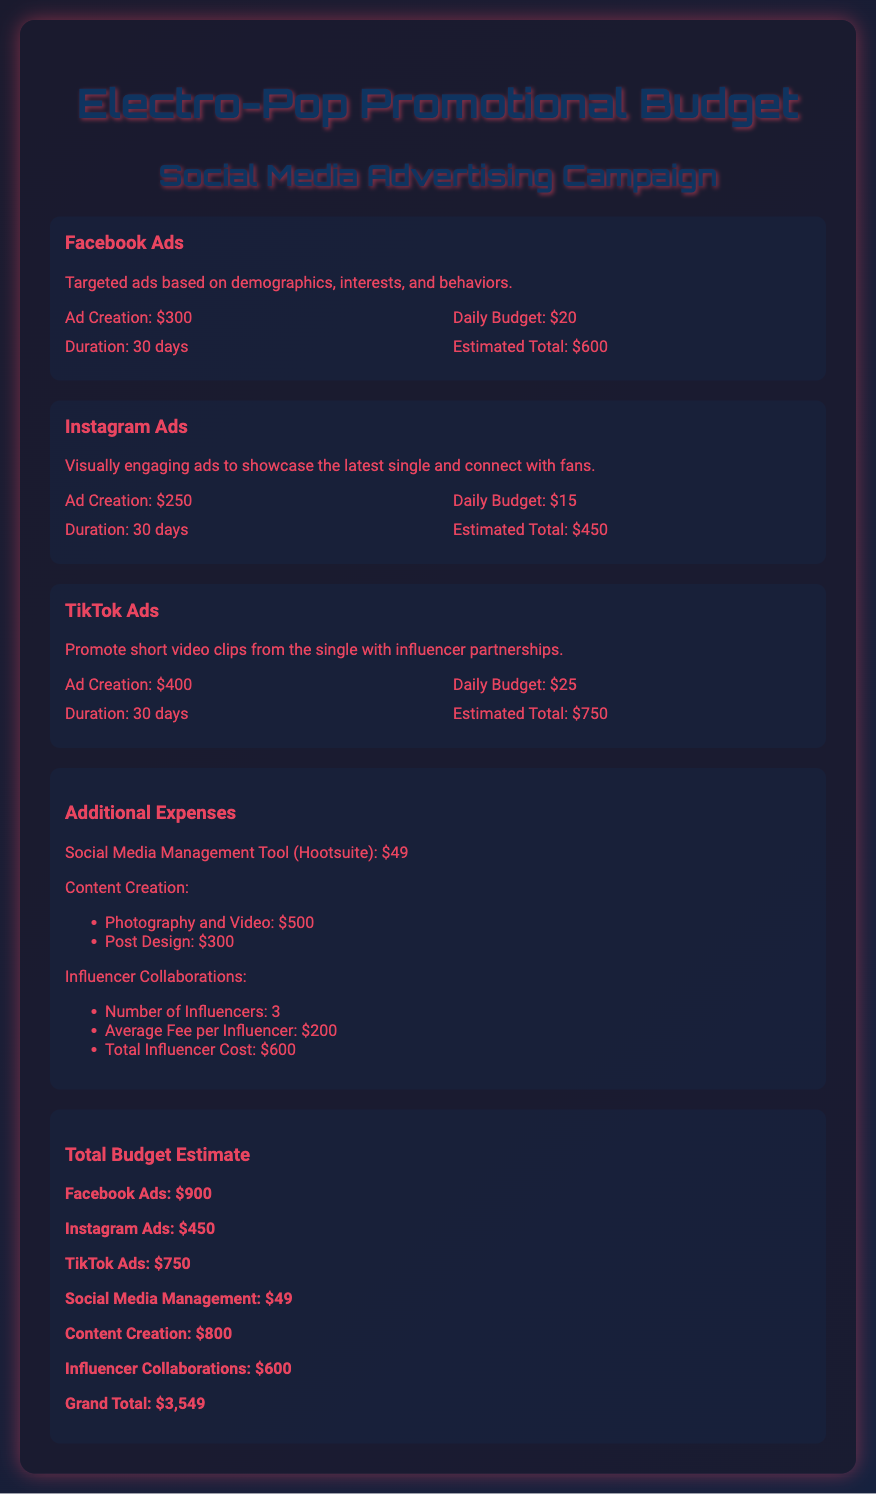What is the total budget for Facebook Ads? The total budget for Facebook Ads is provided under the total budget estimate section of the document, which states $900.
Answer: $900 How much does Ad Creation for TikTok Ads cost? The cost of Ad Creation for TikTok Ads can be found under the TikTok Ads platform section, which lists it as $400.
Answer: $400 What is the daily budget for Instagram Ads? The daily budget for Instagram Ads is specified in the Instagram Ads section, which indicates it is set at $15.
Answer: $15 How many influencers are collaborated with for promotions? The number of influencers listed under Influencer Collaborations in the additional expenses section is 3.
Answer: 3 What is the Grand Total of the promotional budget? The Grand Total is highlighted at the end of the document, which totals to $3,549.
Answer: $3,549 What tool is used for social media management? The tool mentioned for social media management in the additional expenses section is Hootsuite.
Answer: Hootsuite What is the estimated total cost for Instagram Ads? The estimated total cost for Instagram Ads is provided in the total budget estimate section as $450.
Answer: $450 What are the total expenses for Content Creation? The total expenses for Content Creation are calculated by adding the costs of Photography and Video ($500) and Post Design ($300), making it $800.
Answer: $800 